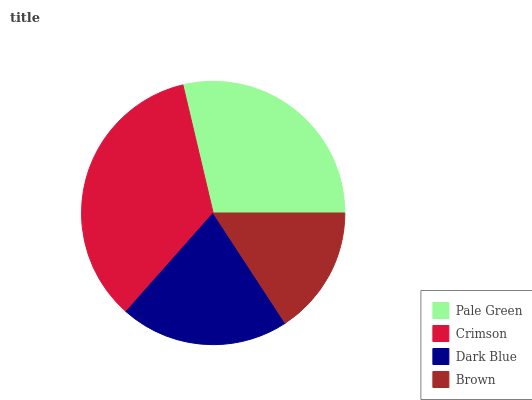Is Brown the minimum?
Answer yes or no. Yes. Is Crimson the maximum?
Answer yes or no. Yes. Is Dark Blue the minimum?
Answer yes or no. No. Is Dark Blue the maximum?
Answer yes or no. No. Is Crimson greater than Dark Blue?
Answer yes or no. Yes. Is Dark Blue less than Crimson?
Answer yes or no. Yes. Is Dark Blue greater than Crimson?
Answer yes or no. No. Is Crimson less than Dark Blue?
Answer yes or no. No. Is Pale Green the high median?
Answer yes or no. Yes. Is Dark Blue the low median?
Answer yes or no. Yes. Is Dark Blue the high median?
Answer yes or no. No. Is Crimson the low median?
Answer yes or no. No. 